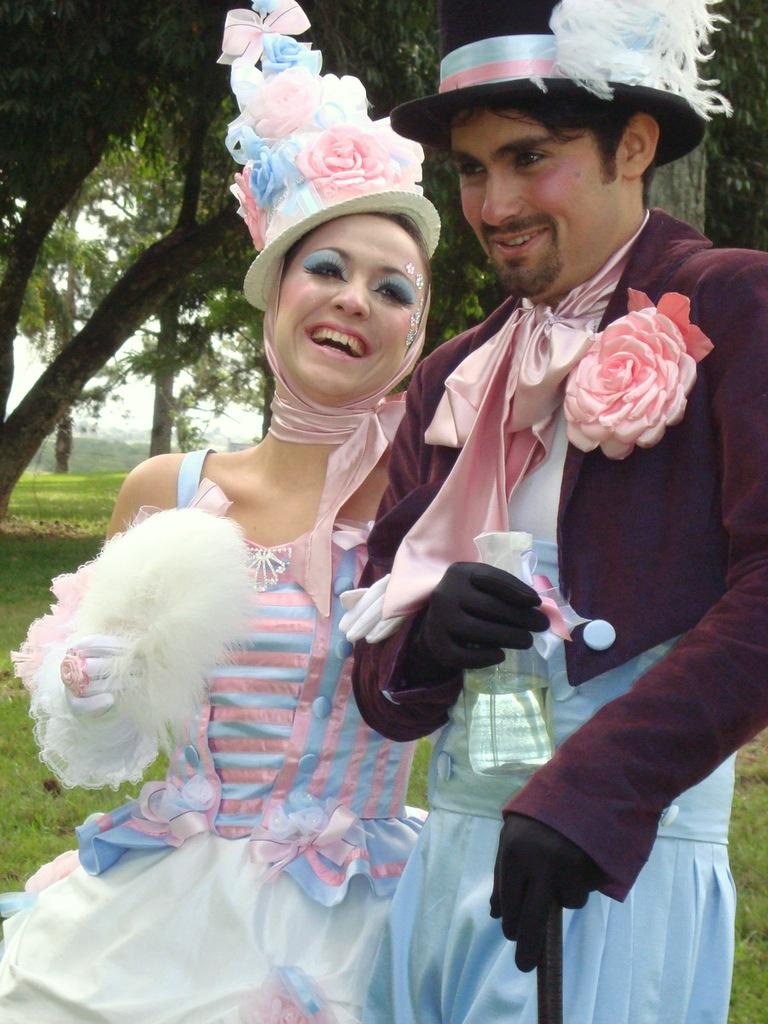How many people are in the image? There are two persons in the image. What are the persons doing in the image? The persons are standing and smiling. What are the persons holding in the image? The persons are holding glasses. What can be seen in the background of the image? Trees and the sky are visible in the background of the image. What type of ground is present at the bottom of the image? Grass is present at the bottom of the image. Where is the table located in the image? There is no table present in the image. What type of pain is the person on the left experiencing in the image? There is no indication of pain or discomfort in the image; both persons are smiling. 